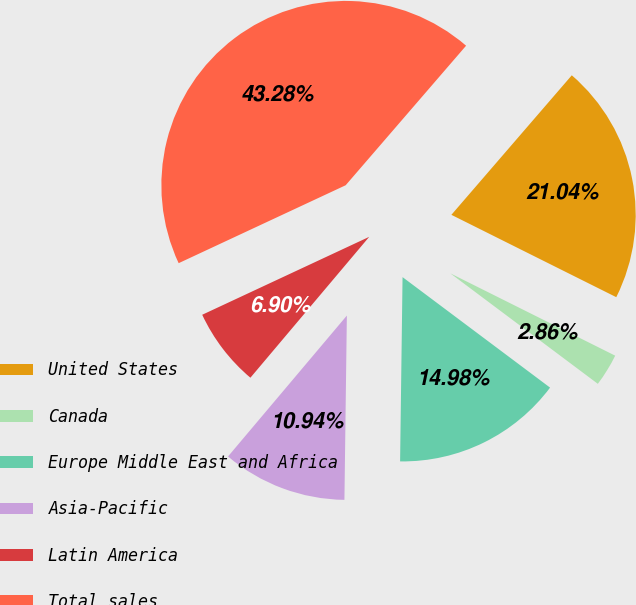Convert chart. <chart><loc_0><loc_0><loc_500><loc_500><pie_chart><fcel>United States<fcel>Canada<fcel>Europe Middle East and Africa<fcel>Asia-Pacific<fcel>Latin America<fcel>Total sales<nl><fcel>21.04%<fcel>2.86%<fcel>14.98%<fcel>10.94%<fcel>6.9%<fcel>43.28%<nl></chart> 